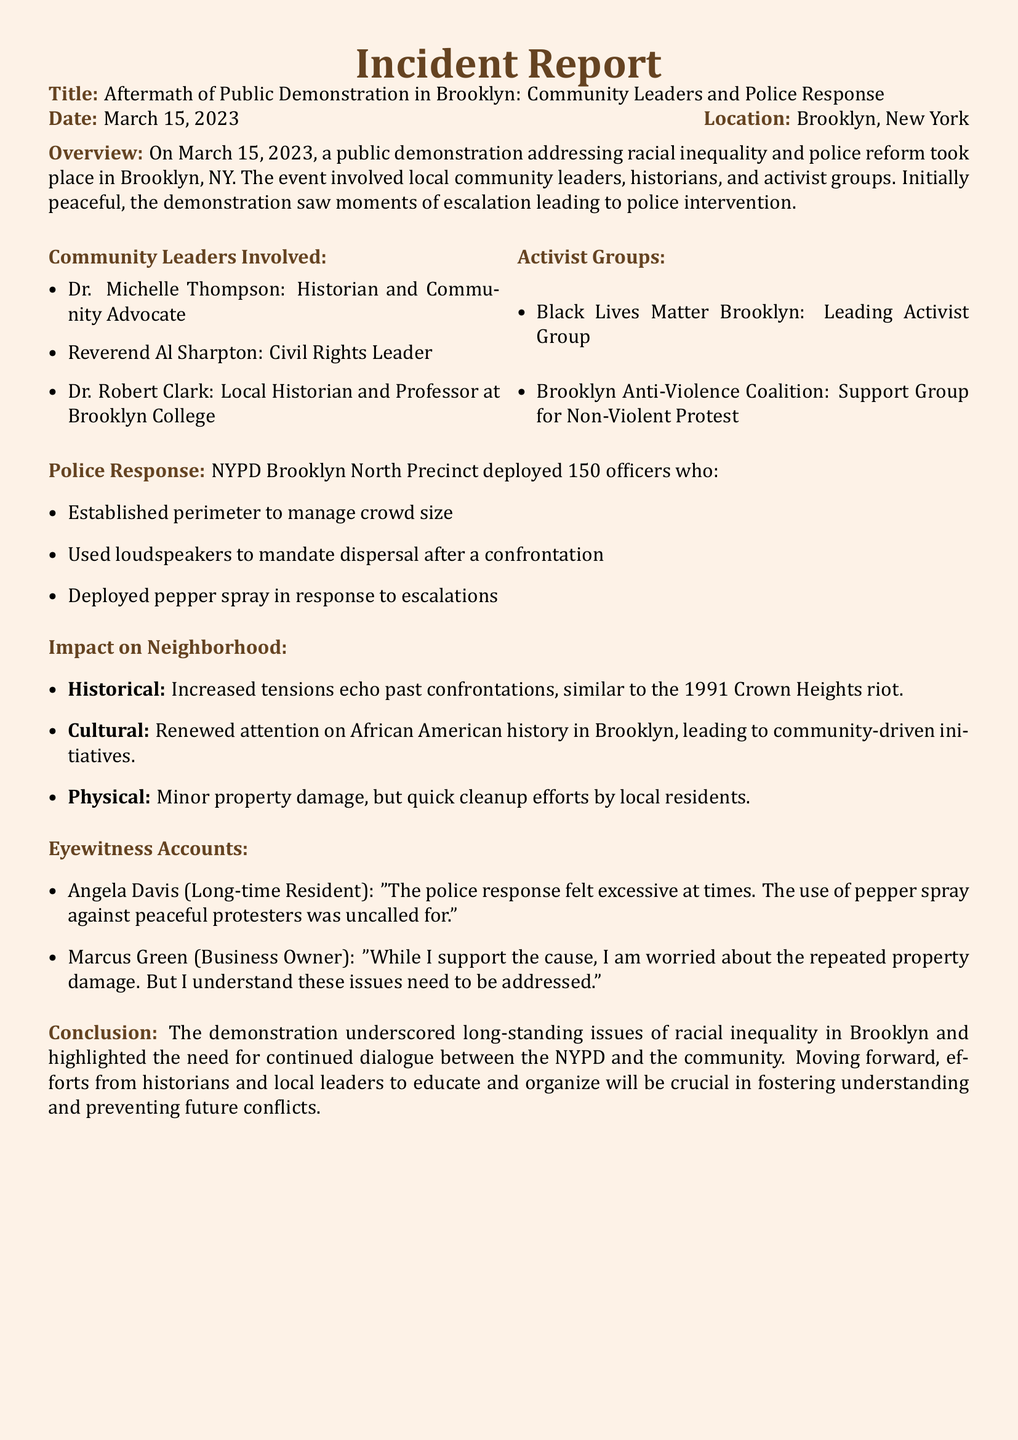What is the title of the incident report? The title provides a clear description of the document's focus, which is "Aftermath of Public Demonstration in Brooklyn: Community Leaders and Police Response."
Answer: Aftermath of Public Demonstration in Brooklyn: Community Leaders and Police Response Who is a local historian mentioned in the document? The document lists three community leaders, one of whom is a local historian and professor.
Answer: Dr. Robert Clark What date did the demonstration take place? The date is specified in the report as the day the events occurred.
Answer: March 15, 2023 How many officers were deployed by the NYPD? The deployment of officers is noted in the police response section of the report.
Answer: 150 officers Which activist group was identified as the leading activist group? The report names the group that led the protest among the activist groups mentioned.
Answer: Black Lives Matter Brooklyn What specific action did the police take in response to confrontations? Police actions during the demonstration are detailed, particularly in response to escalating situations.
Answer: Deployed pepper spray What were the two main impacts on the neighborhood? The document outlines historical and cultural impacts, emphasizing specific aspects related to the demonstration's aftermath.
Answer: Increased tensions and renewed attention on African American history in Brooklyn Who expressed concerns about property damage during the demonstration? Eyewitness accounts include specific individuals' perspectives, including concerns from a business owner.
Answer: Marcus Green What historical event is mentioned in relation to increased tensions? The report draws parallels to past events to provide context for the current situation.
Answer: 1991 Crown Heights riot 